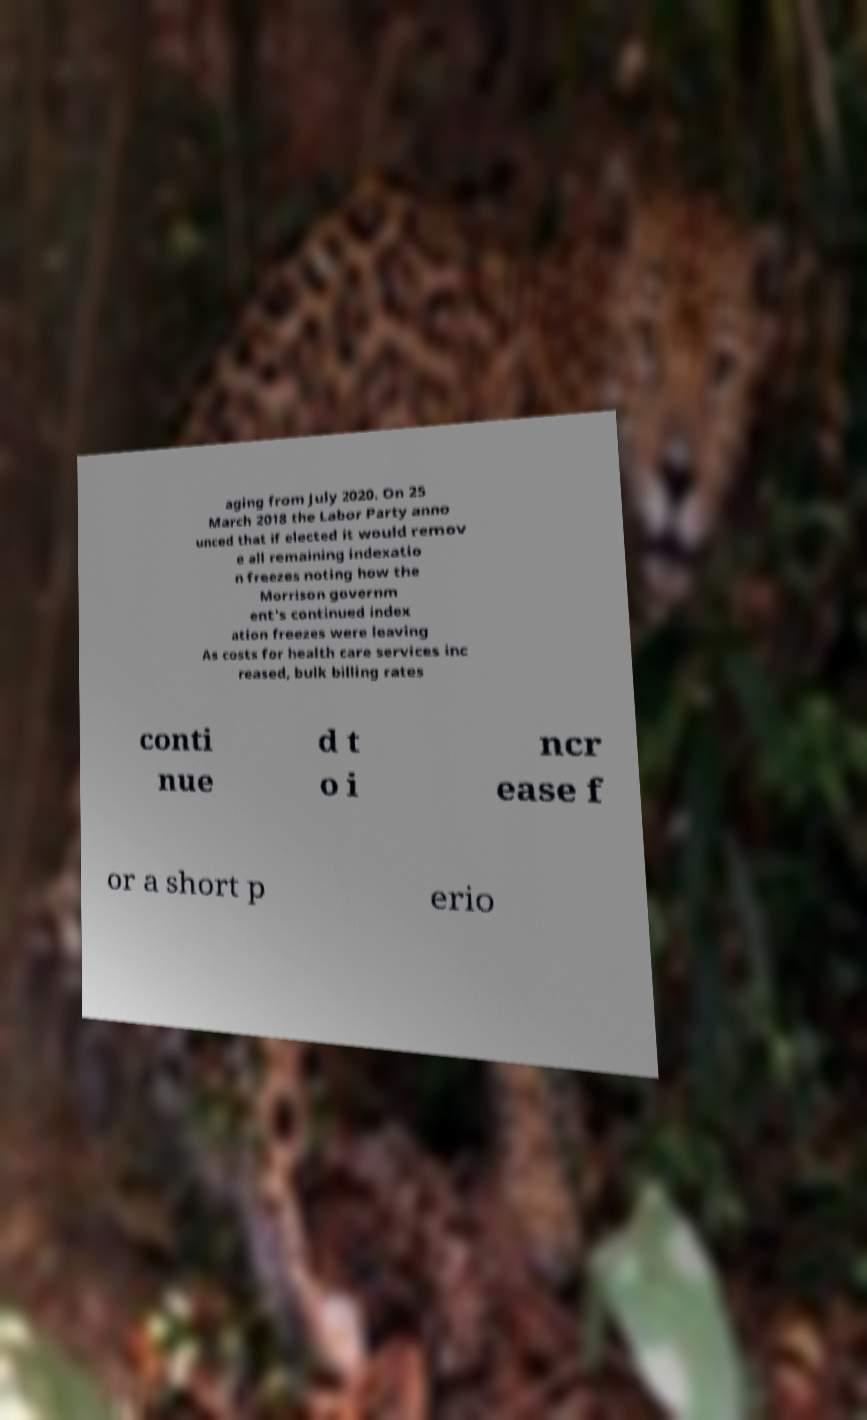Can you accurately transcribe the text from the provided image for me? aging from July 2020. On 25 March 2018 the Labor Party anno unced that if elected it would remov e all remaining indexatio n freezes noting how the Morrison governm ent's continued index ation freezes were leaving As costs for health care services inc reased, bulk billing rates conti nue d t o i ncr ease f or a short p erio 